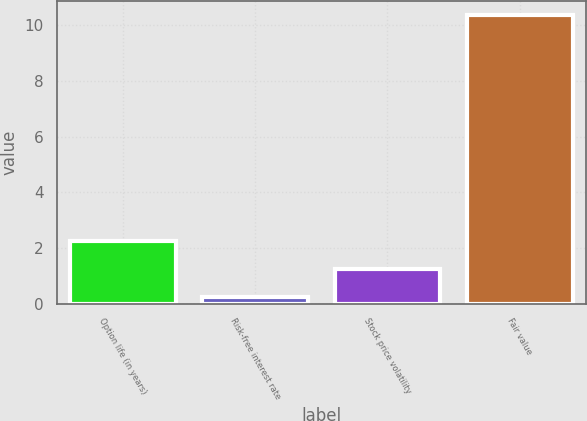Convert chart to OTSL. <chart><loc_0><loc_0><loc_500><loc_500><bar_chart><fcel>Option life (in years)<fcel>Risk-free interest rate<fcel>Stock price volatility<fcel>Fair value<nl><fcel>2.25<fcel>0.23<fcel>1.24<fcel>10.36<nl></chart> 